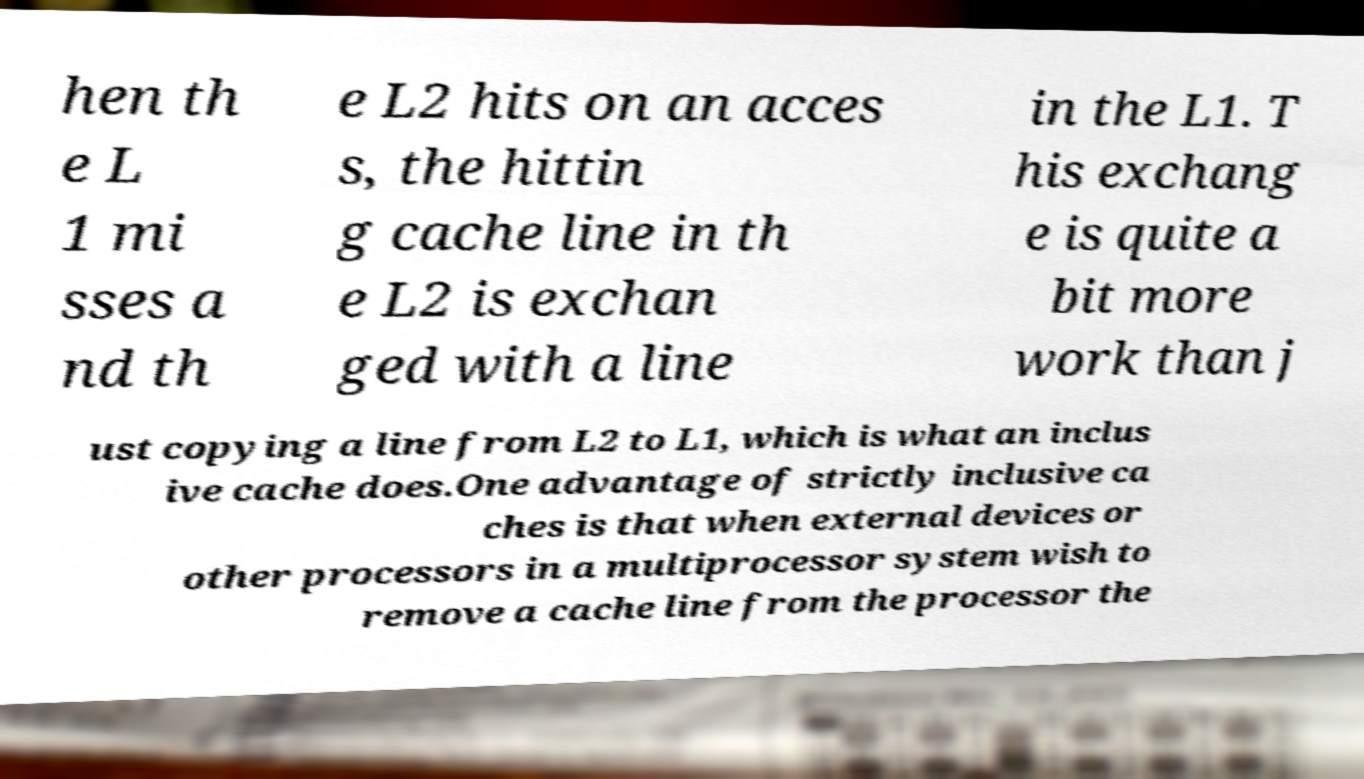Please read and relay the text visible in this image. What does it say? hen th e L 1 mi sses a nd th e L2 hits on an acces s, the hittin g cache line in th e L2 is exchan ged with a line in the L1. T his exchang e is quite a bit more work than j ust copying a line from L2 to L1, which is what an inclus ive cache does.One advantage of strictly inclusive ca ches is that when external devices or other processors in a multiprocessor system wish to remove a cache line from the processor the 